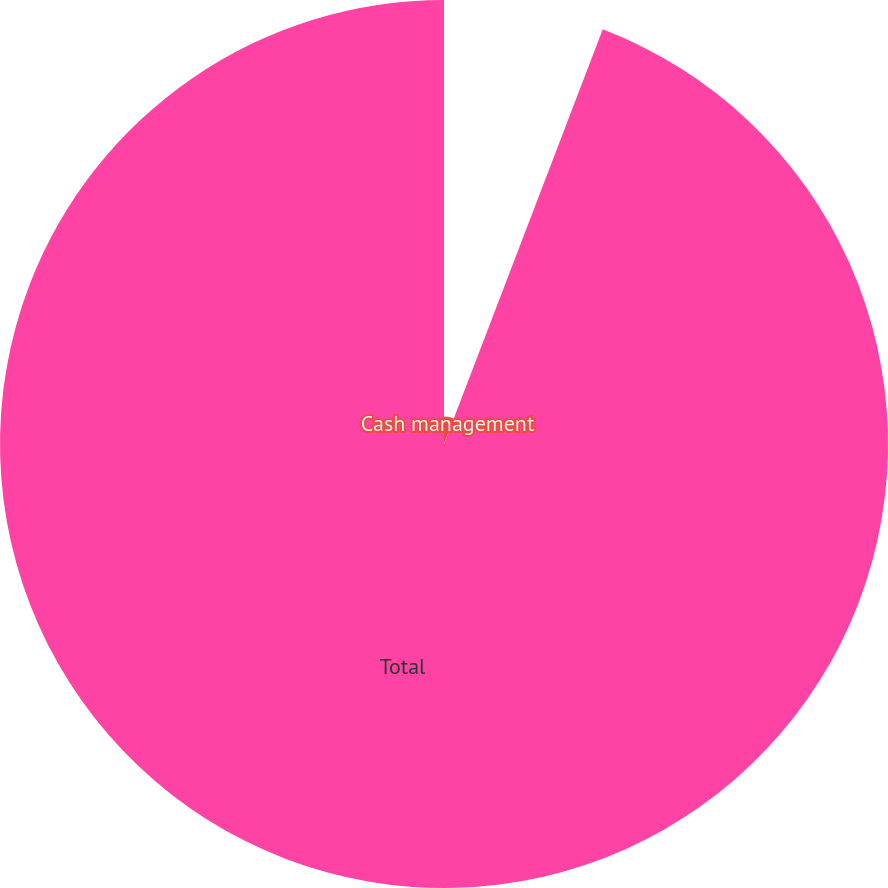Convert chart to OTSL. <chart><loc_0><loc_0><loc_500><loc_500><pie_chart><fcel>Cash management<fcel>Total<nl><fcel>5.82%<fcel>94.18%<nl></chart> 